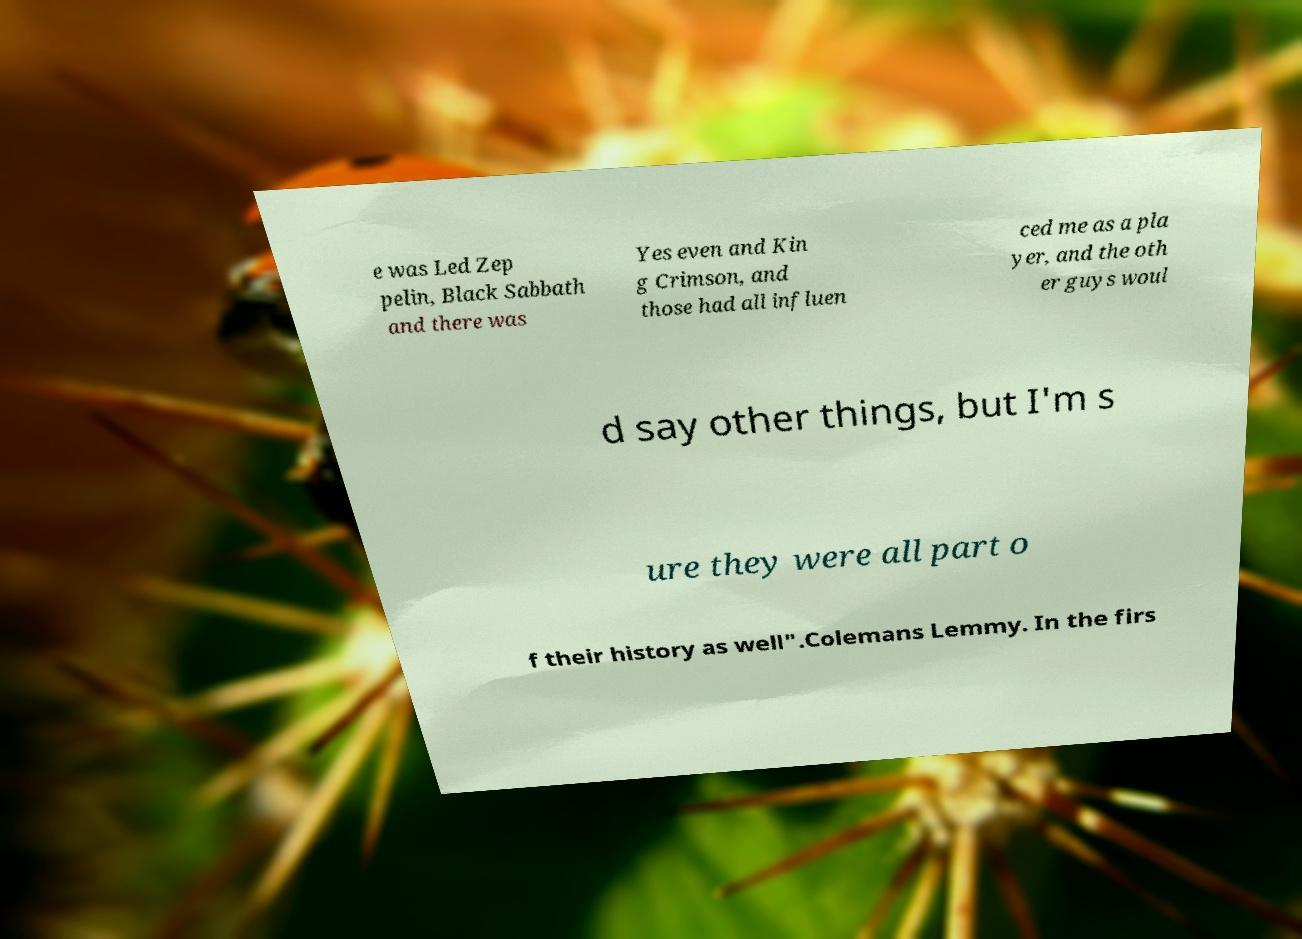Please read and relay the text visible in this image. What does it say? e was Led Zep pelin, Black Sabbath and there was Yes even and Kin g Crimson, and those had all influen ced me as a pla yer, and the oth er guys woul d say other things, but I'm s ure they were all part o f their history as well".Colemans Lemmy. In the firs 